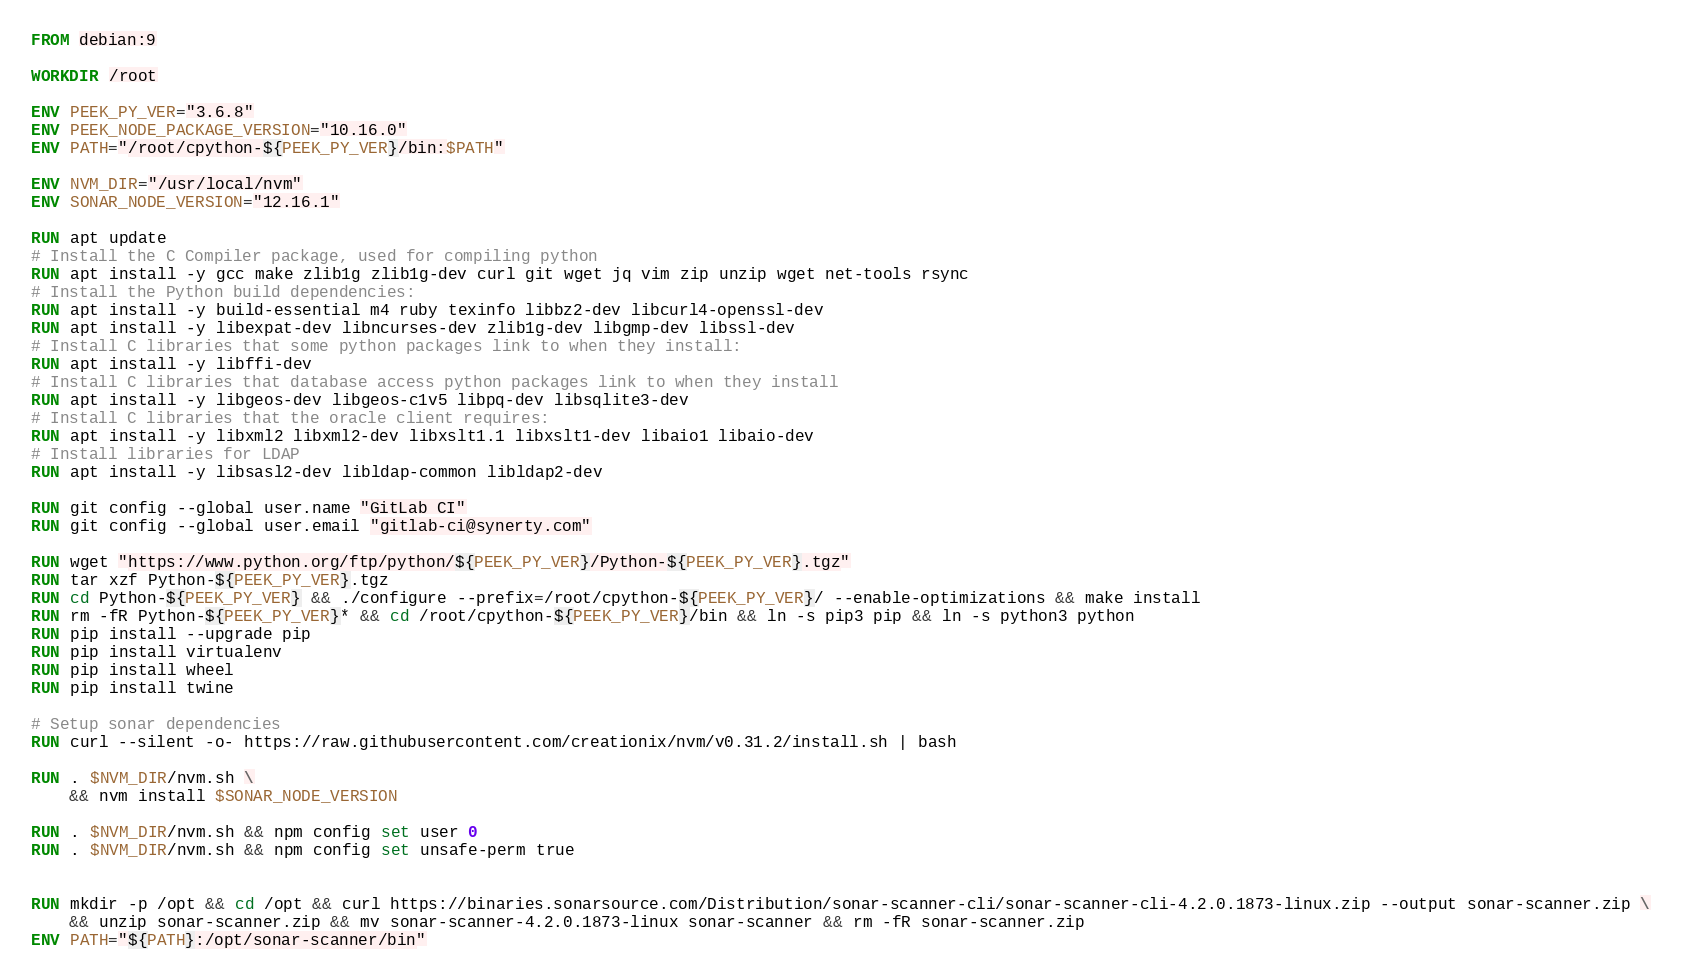Convert code to text. <code><loc_0><loc_0><loc_500><loc_500><_Dockerfile_>FROM debian:9

WORKDIR /root

ENV PEEK_PY_VER="3.6.8"
ENV PEEK_NODE_PACKAGE_VERSION="10.16.0"
ENV PATH="/root/cpython-${PEEK_PY_VER}/bin:$PATH"

ENV NVM_DIR="/usr/local/nvm"
ENV SONAR_NODE_VERSION="12.16.1"

RUN apt update
# Install the C Compiler package, used for compiling python
RUN apt install -y gcc make zlib1g zlib1g-dev curl git wget jq vim zip unzip wget net-tools rsync
# Install the Python build dependencies:
RUN apt install -y build-essential m4 ruby texinfo libbz2-dev libcurl4-openssl-dev
RUN apt install -y libexpat-dev libncurses-dev zlib1g-dev libgmp-dev libssl-dev
# Install C libraries that some python packages link to when they install:
RUN apt install -y libffi-dev
# Install C libraries that database access python packages link to when they install
RUN apt install -y libgeos-dev libgeos-c1v5 libpq-dev libsqlite3-dev
# Install C libraries that the oracle client requires:
RUN apt install -y libxml2 libxml2-dev libxslt1.1 libxslt1-dev libaio1 libaio-dev
# Install libraries for LDAP
RUN apt install -y libsasl2-dev libldap-common libldap2-dev

RUN git config --global user.name "GitLab CI"
RUN git config --global user.email "gitlab-ci@synerty.com"

RUN wget "https://www.python.org/ftp/python/${PEEK_PY_VER}/Python-${PEEK_PY_VER}.tgz"
RUN tar xzf Python-${PEEK_PY_VER}.tgz
RUN cd Python-${PEEK_PY_VER} && ./configure --prefix=/root/cpython-${PEEK_PY_VER}/ --enable-optimizations && make install
RUN rm -fR Python-${PEEK_PY_VER}* && cd /root/cpython-${PEEK_PY_VER}/bin && ln -s pip3 pip && ln -s python3 python
RUN pip install --upgrade pip
RUN pip install virtualenv
RUN pip install wheel
RUN pip install twine

# Setup sonar dependencies
RUN curl --silent -o- https://raw.githubusercontent.com/creationix/nvm/v0.31.2/install.sh | bash

RUN . $NVM_DIR/nvm.sh \
    && nvm install $SONAR_NODE_VERSION

RUN . $NVM_DIR/nvm.sh && npm config set user 0
RUN . $NVM_DIR/nvm.sh && npm config set unsafe-perm true


RUN mkdir -p /opt && cd /opt && curl https://binaries.sonarsource.com/Distribution/sonar-scanner-cli/sonar-scanner-cli-4.2.0.1873-linux.zip --output sonar-scanner.zip \
    && unzip sonar-scanner.zip && mv sonar-scanner-4.2.0.1873-linux sonar-scanner && rm -fR sonar-scanner.zip
ENV PATH="${PATH}:/opt/sonar-scanner/bin"


</code> 